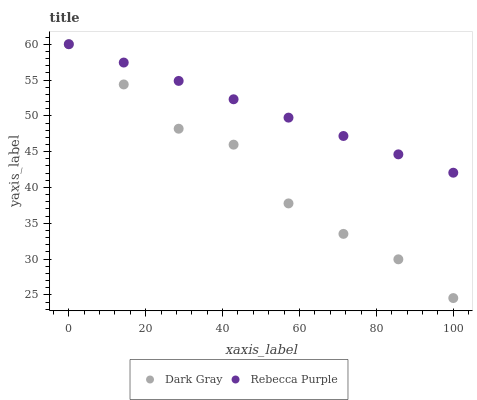Does Dark Gray have the minimum area under the curve?
Answer yes or no. Yes. Does Rebecca Purple have the maximum area under the curve?
Answer yes or no. Yes. Does Rebecca Purple have the minimum area under the curve?
Answer yes or no. No. Is Rebecca Purple the smoothest?
Answer yes or no. Yes. Is Dark Gray the roughest?
Answer yes or no. Yes. Is Rebecca Purple the roughest?
Answer yes or no. No. Does Dark Gray have the lowest value?
Answer yes or no. Yes. Does Rebecca Purple have the lowest value?
Answer yes or no. No. Does Rebecca Purple have the highest value?
Answer yes or no. Yes. Does Rebecca Purple intersect Dark Gray?
Answer yes or no. Yes. Is Rebecca Purple less than Dark Gray?
Answer yes or no. No. Is Rebecca Purple greater than Dark Gray?
Answer yes or no. No. 